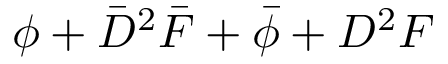<formula> <loc_0><loc_0><loc_500><loc_500>\phi + \bar { D } ^ { 2 } \bar { F } + \bar { \phi } + D ^ { 2 } F</formula> 